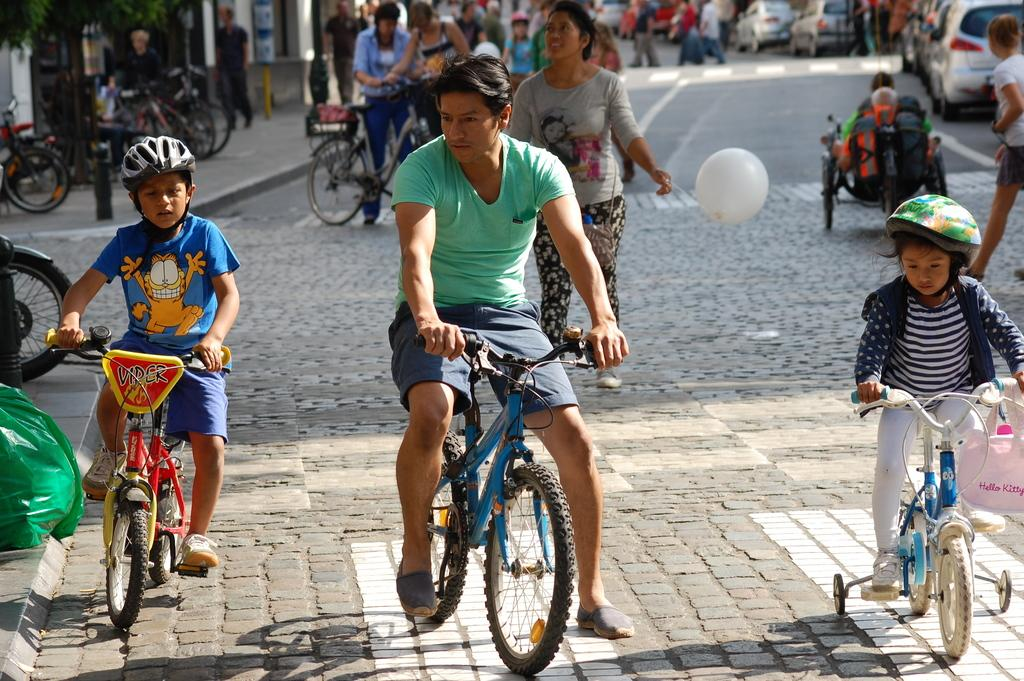What is happening in the image involving a group of people? There is a group of people in the image, and some of them are riding bicycles. What else can be seen on the road in the image? There is a car on the road in the image. Are there any objects being held by the people in the image? Yes, one person is holding a balloon in the image. Where are the kittens playing in the image? There are no kittens present in the image. What type of chicken can be seen crossing the road in the image? There is no chicken present in the image; it only features a car on the road. 